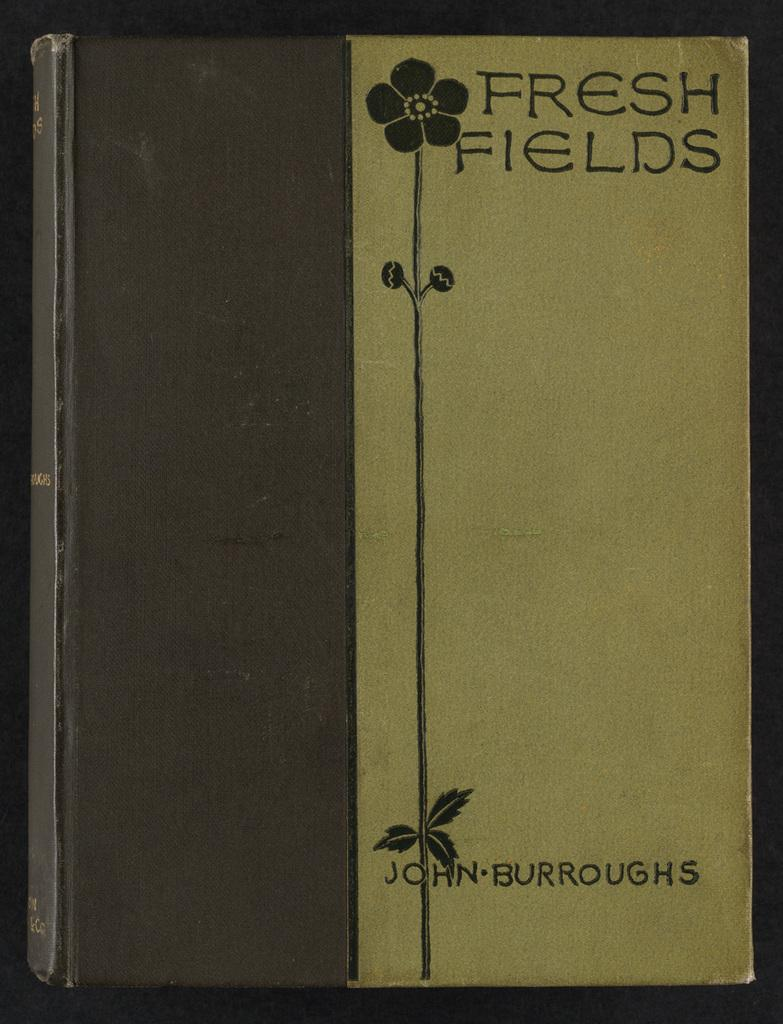<image>
Present a compact description of the photo's key features. A book cover has a flower and the author name John Burroughs on it. 